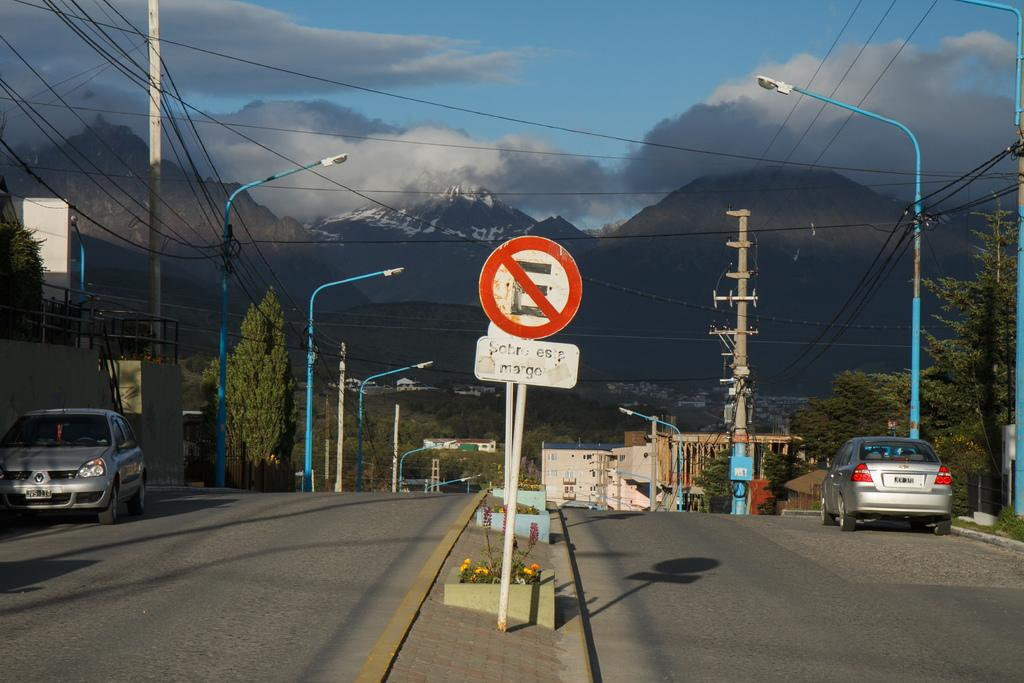What is attached to a pole in the image? There is a signboard attached to a pole in the image. What can be seen on the road in the image? There are vehicles on the road in the image. What is present in the image that provides illumination? There are lights in the image. What else can be seen attached to poles in the image? There are poles in the image. What type of vegetation is present in the image? There are trees and plants in the image. What type of structures are visible in the image? There are buildings in the image. What type of natural landform is visible in the image? There are hills in the image. What is visible in the background of the image? The sky is visible in the background of the image. Who is the judge presiding over the trial in the image? There is no trial or judge present in the image. What is the relation between the trees and the plants in the image? The trees and plants are separate types of vegetation in the image, but there is no direct relation between them. 